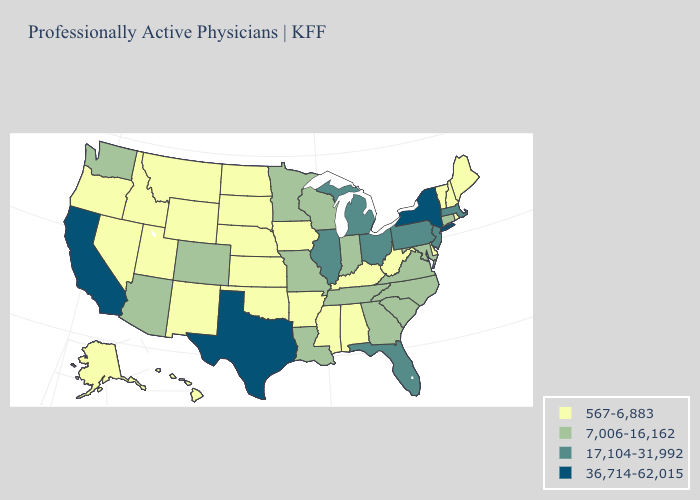What is the lowest value in the USA?
Be succinct. 567-6,883. Among the states that border Florida , which have the lowest value?
Quick response, please. Alabama. Which states have the lowest value in the USA?
Answer briefly. Alabama, Alaska, Arkansas, Delaware, Hawaii, Idaho, Iowa, Kansas, Kentucky, Maine, Mississippi, Montana, Nebraska, Nevada, New Hampshire, New Mexico, North Dakota, Oklahoma, Oregon, Rhode Island, South Dakota, Utah, Vermont, West Virginia, Wyoming. What is the highest value in the South ?
Short answer required. 36,714-62,015. What is the value of Wyoming?
Short answer required. 567-6,883. How many symbols are there in the legend?
Write a very short answer. 4. What is the value of Vermont?
Be succinct. 567-6,883. Among the states that border Oklahoma , which have the highest value?
Write a very short answer. Texas. Does Texas have the highest value in the USA?
Quick response, please. Yes. Does Iowa have the same value as Michigan?
Quick response, please. No. What is the value of Kentucky?
Short answer required. 567-6,883. Name the states that have a value in the range 36,714-62,015?
Short answer required. California, New York, Texas. Does the map have missing data?
Quick response, please. No. Name the states that have a value in the range 36,714-62,015?
Be succinct. California, New York, Texas. 